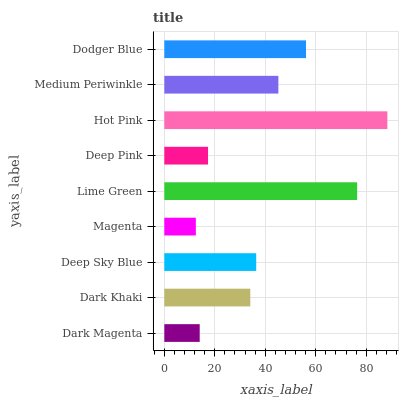Is Magenta the minimum?
Answer yes or no. Yes. Is Hot Pink the maximum?
Answer yes or no. Yes. Is Dark Khaki the minimum?
Answer yes or no. No. Is Dark Khaki the maximum?
Answer yes or no. No. Is Dark Khaki greater than Dark Magenta?
Answer yes or no. Yes. Is Dark Magenta less than Dark Khaki?
Answer yes or no. Yes. Is Dark Magenta greater than Dark Khaki?
Answer yes or no. No. Is Dark Khaki less than Dark Magenta?
Answer yes or no. No. Is Deep Sky Blue the high median?
Answer yes or no. Yes. Is Deep Sky Blue the low median?
Answer yes or no. Yes. Is Dark Magenta the high median?
Answer yes or no. No. Is Lime Green the low median?
Answer yes or no. No. 